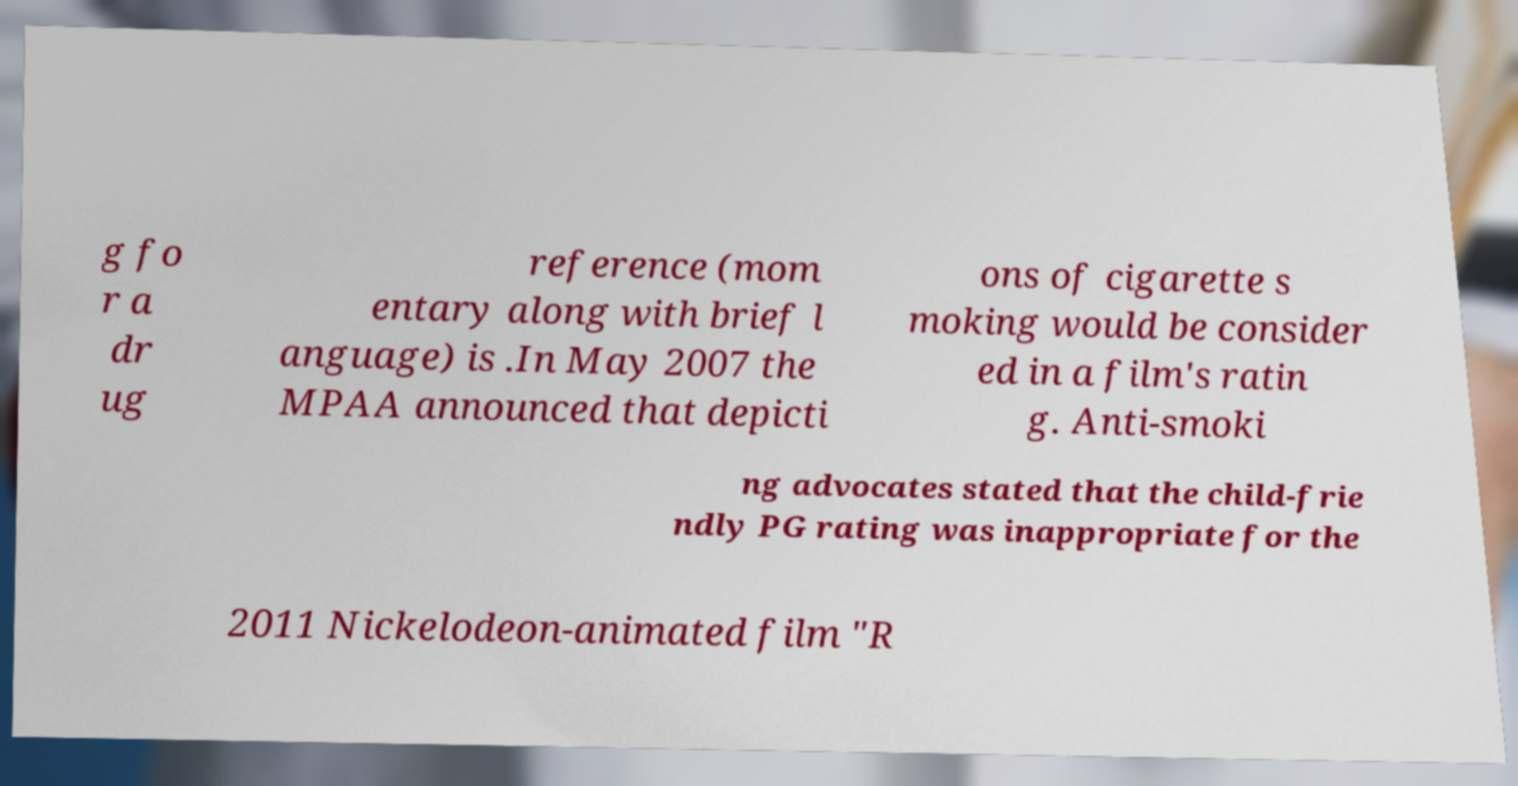Could you extract and type out the text from this image? g fo r a dr ug reference (mom entary along with brief l anguage) is .In May 2007 the MPAA announced that depicti ons of cigarette s moking would be consider ed in a film's ratin g. Anti-smoki ng advocates stated that the child-frie ndly PG rating was inappropriate for the 2011 Nickelodeon-animated film "R 